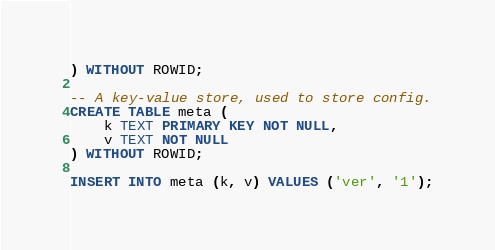<code> <loc_0><loc_0><loc_500><loc_500><_SQL_>) WITHOUT ROWID;

-- A key-value store, used to store config.
CREATE TABLE meta (
    k TEXT PRIMARY KEY NOT NULL,
    v TEXT NOT NULL
) WITHOUT ROWID;

INSERT INTO meta (k, v) VALUES ('ver', '1');
</code> 